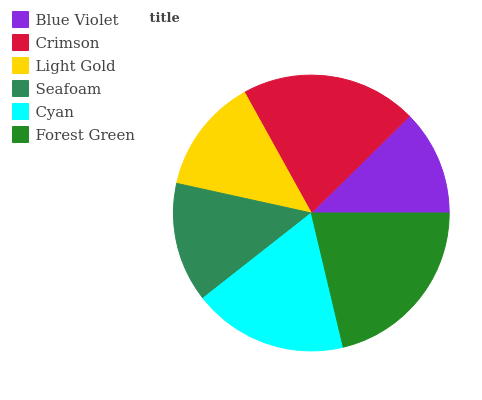Is Blue Violet the minimum?
Answer yes or no. Yes. Is Forest Green the maximum?
Answer yes or no. Yes. Is Crimson the minimum?
Answer yes or no. No. Is Crimson the maximum?
Answer yes or no. No. Is Crimson greater than Blue Violet?
Answer yes or no. Yes. Is Blue Violet less than Crimson?
Answer yes or no. Yes. Is Blue Violet greater than Crimson?
Answer yes or no. No. Is Crimson less than Blue Violet?
Answer yes or no. No. Is Cyan the high median?
Answer yes or no. Yes. Is Seafoam the low median?
Answer yes or no. Yes. Is Crimson the high median?
Answer yes or no. No. Is Forest Green the low median?
Answer yes or no. No. 